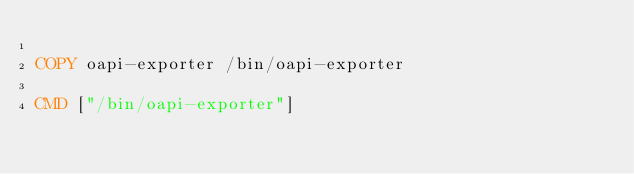Convert code to text. <code><loc_0><loc_0><loc_500><loc_500><_Dockerfile_>
COPY oapi-exporter /bin/oapi-exporter

CMD ["/bin/oapi-exporter"]

</code> 